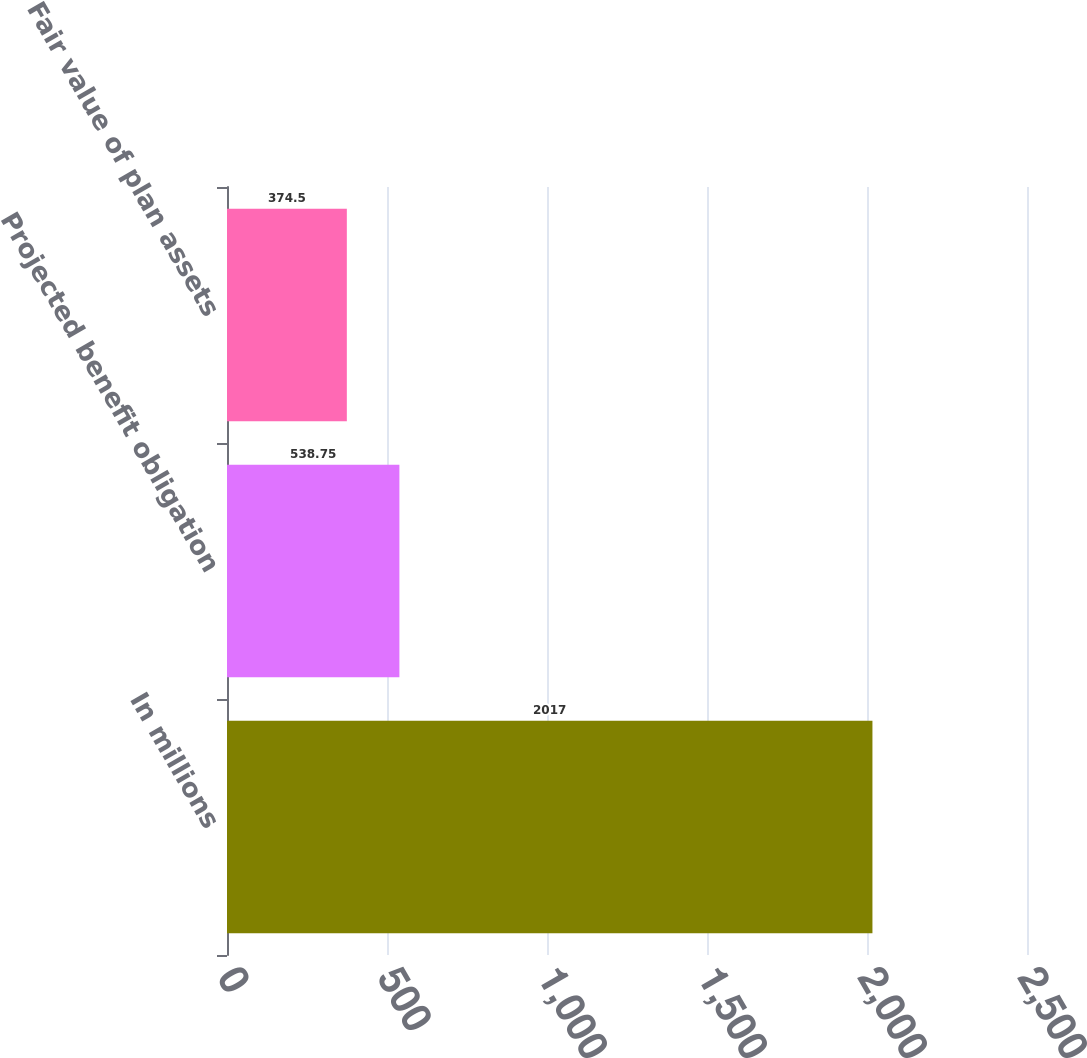Convert chart. <chart><loc_0><loc_0><loc_500><loc_500><bar_chart><fcel>In millions<fcel>Projected benefit obligation<fcel>Fair value of plan assets<nl><fcel>2017<fcel>538.75<fcel>374.5<nl></chart> 